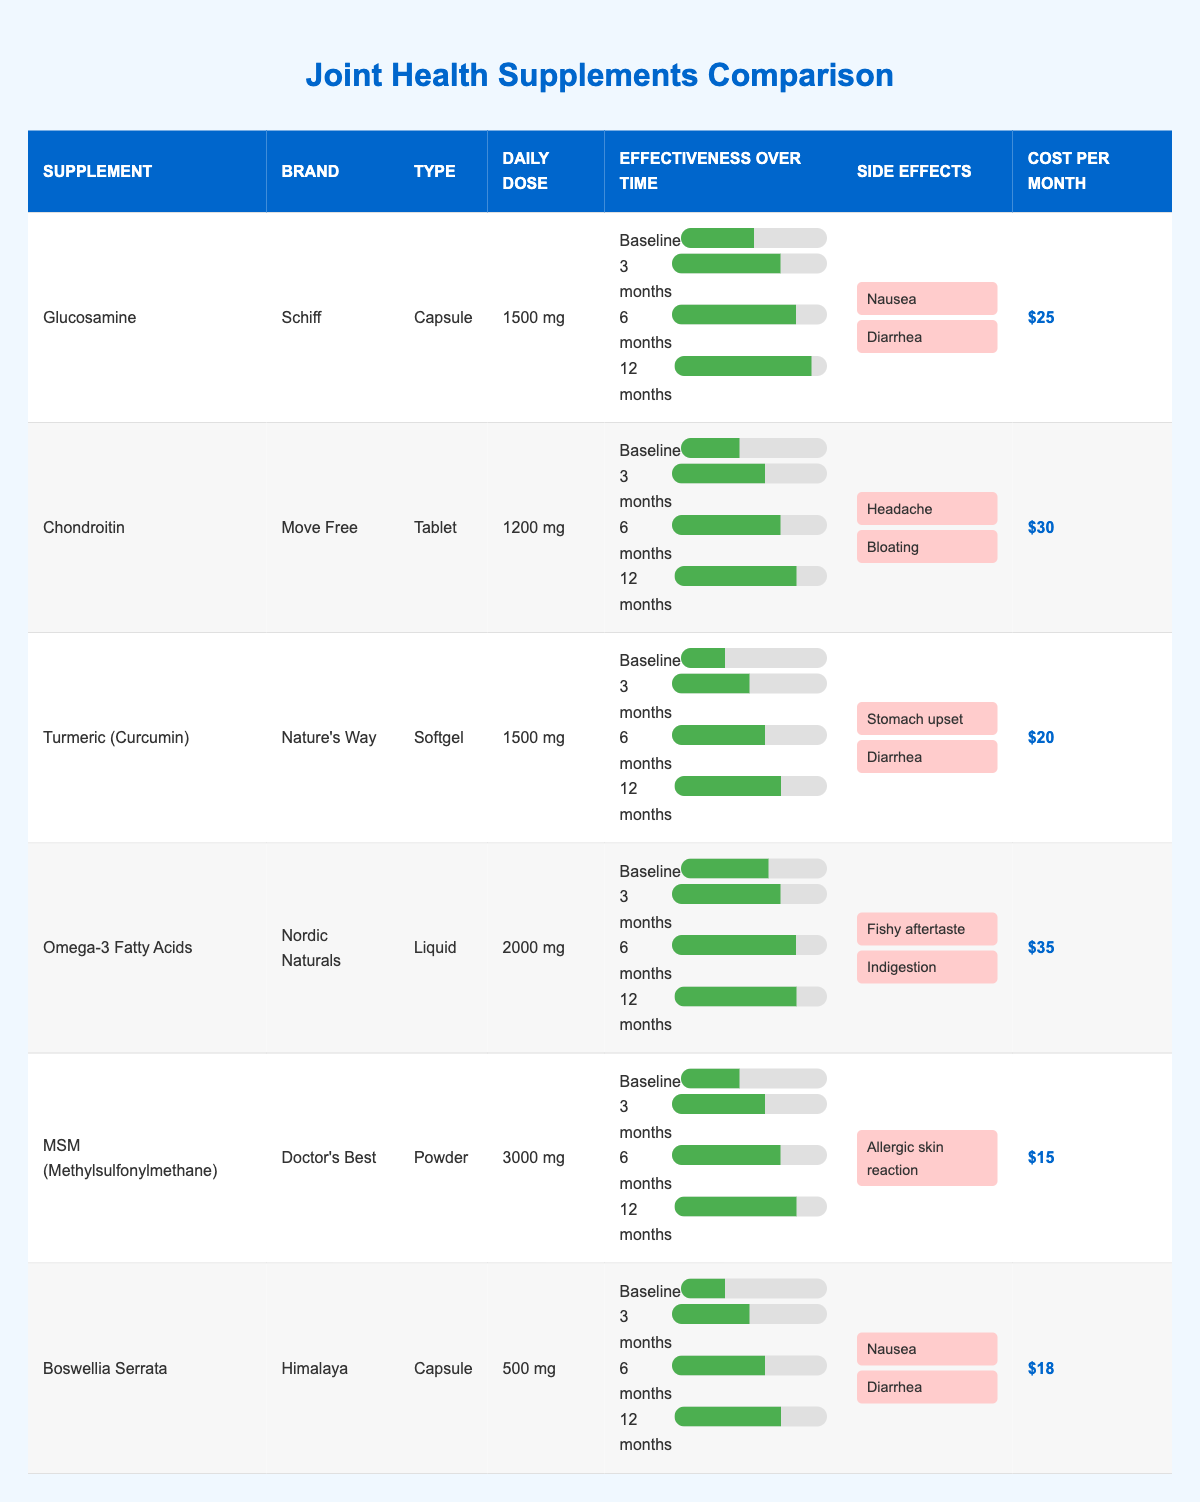What is the effectiveness score of Glucosamine at 6 months? The effectiveness score for Glucosamine at 6 months is 8 according to the table.
Answer: 8 Which supplement has the highest cost per month? The costs per month of the supplements are $25 for Glucosamine, $30 for Chondroitin, $20 for Turmeric, $35 for Omega-3, $15 for MSM, and $18 for Boswellia. Omega-3 Fatty Acids has the highest cost at $35.
Answer: $35 How many supplements show an effectiveness increase from baseline to 12 months? By comparing the effectiveness scores from baseline to 12 months: Glucosamine (5 to 9), Chondroitin (4 to 8), Turmeric (3 to 7), Omega-3 (6 to 8), MSM (4 to 8), and Boswellia (3 to 7) all increase, totaling 6 supplements.
Answer: 6 What is the average daily dose of all supplements? The daily doses are: 1500 mg (Glucosamine), 1200 mg (Chondroitin), 1500 mg (Turmeric), 2000 mg (Omega-3), 3000 mg (MSM), and 500 mg (Boswellia). Adding these gives: 1500 + 1200 + 1500 + 2000 + 3000 + 500 = 10700 mg. Dividing by 6 gives an average of 1783.33 mg.
Answer: 1783.33 mg Does Chondroitin have any side effects? Yes, the side effects listed for Chondroitin are headache and bloating, which confirms it has side effects.
Answer: Yes Which supplement type has the lowest effectiveness score at baseline? The baseline effectiveness scores are: Glucosamine (5), Chondroitin (4), Turmeric (3), Omega-3 (6), MSM (4), and Boswellia (3). The lowest score is Turmeric with a score of 3.
Answer: Turmeric What are the common side effects among the supplements? The side effects are: Glucosamine (Nausea, Diarrhea), Chondroitin (Headache, Bloating), Turmeric (Stomach upset, Diarrhea), Omega-3 (Fishy aftertaste, Indigestion), MSM (Allergic skin reaction), and Boswellia (Nausea, Diarrhea). Diarrhea and Nausea are common among Glucosamine and Boswellia.
Answer: Diarrhea, Nausea Which supplement shows the most consistent effectiveness scores over time? Checking effectiveness over time: Omega-3 maintains a score of 8 from 6 months to 12 months while others show variations. This indicates it’s the most consistent.
Answer: Omega-3 Fatty Acids 